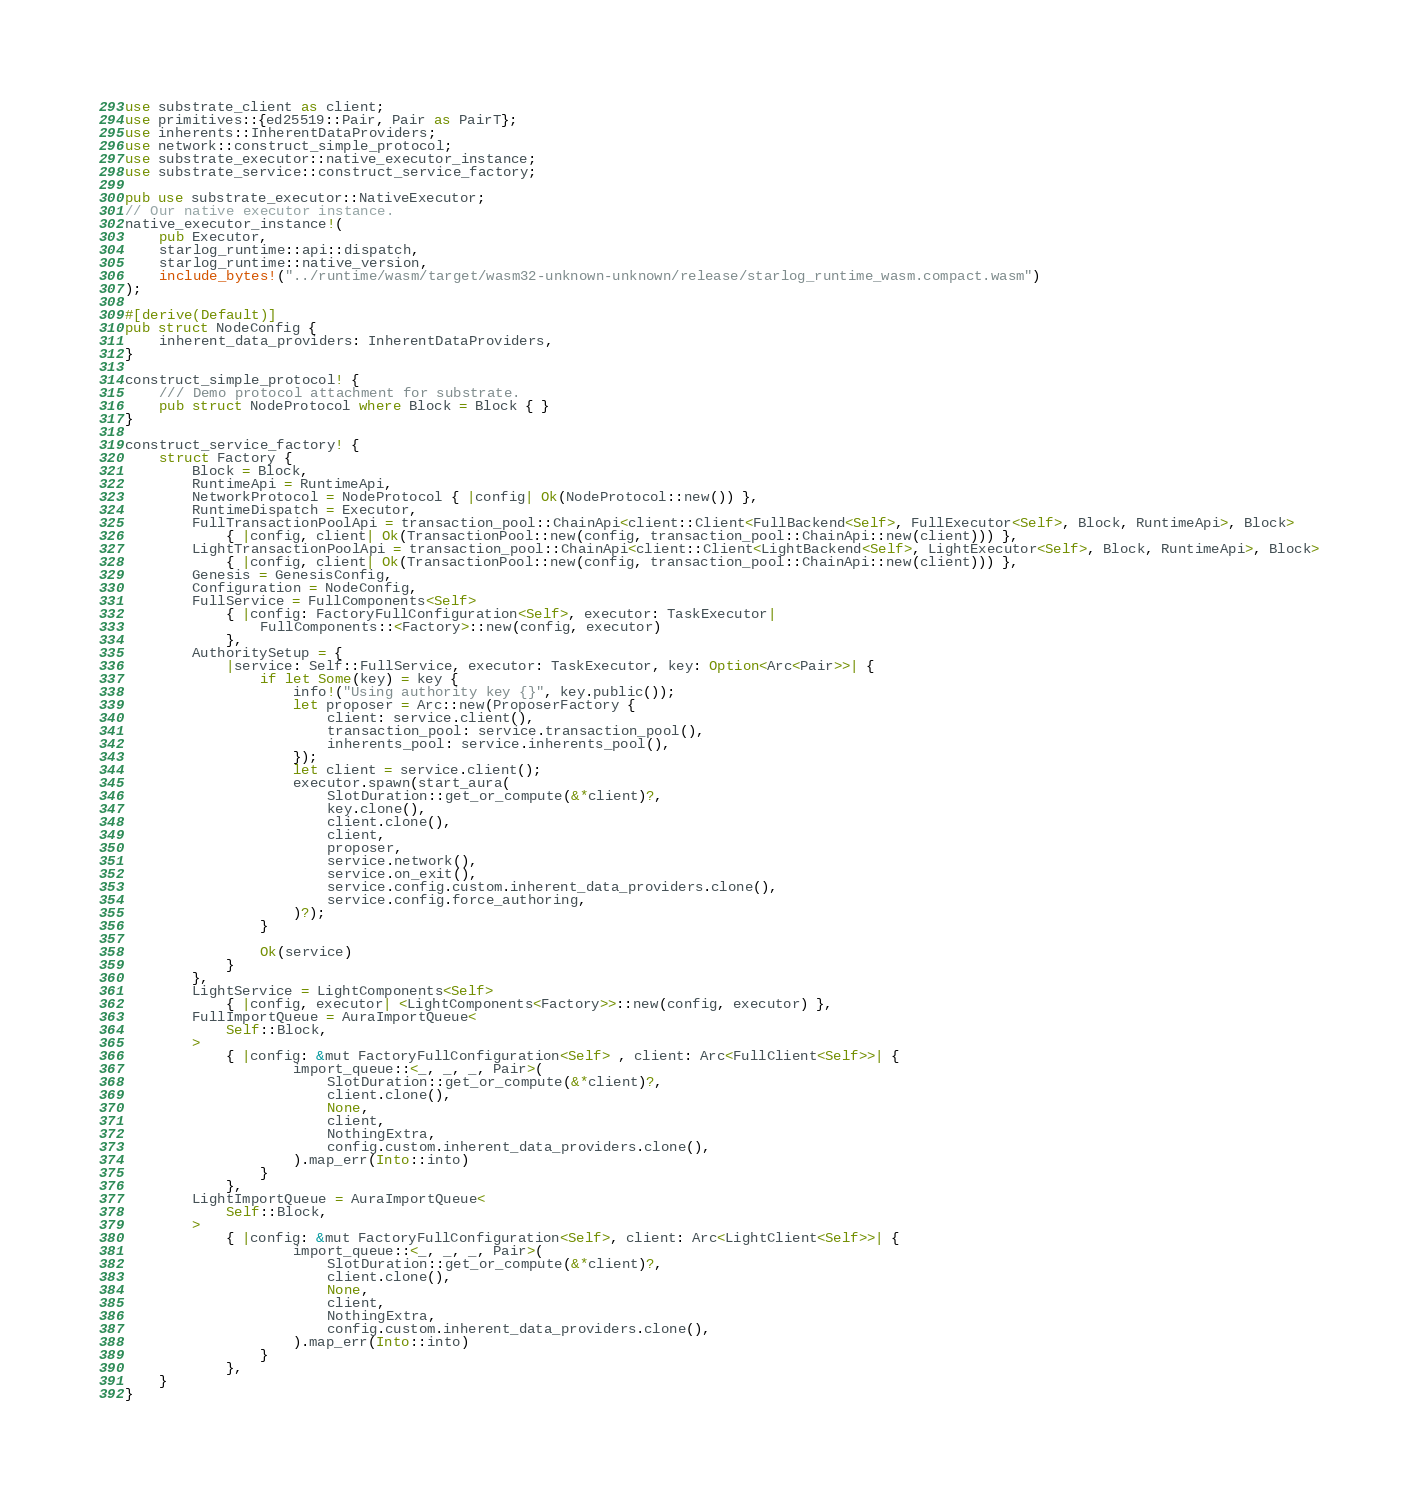Convert code to text. <code><loc_0><loc_0><loc_500><loc_500><_Rust_>use substrate_client as client;
use primitives::{ed25519::Pair, Pair as PairT};
use inherents::InherentDataProviders;
use network::construct_simple_protocol;
use substrate_executor::native_executor_instance;
use substrate_service::construct_service_factory;

pub use substrate_executor::NativeExecutor;
// Our native executor instance.
native_executor_instance!(
	pub Executor,
	starlog_runtime::api::dispatch,
	starlog_runtime::native_version,
	include_bytes!("../runtime/wasm/target/wasm32-unknown-unknown/release/starlog_runtime_wasm.compact.wasm")
);

#[derive(Default)]
pub struct NodeConfig {
	inherent_data_providers: InherentDataProviders,
}

construct_simple_protocol! {
	/// Demo protocol attachment for substrate.
	pub struct NodeProtocol where Block = Block { }
}

construct_service_factory! {
	struct Factory {
		Block = Block,
		RuntimeApi = RuntimeApi,
		NetworkProtocol = NodeProtocol { |config| Ok(NodeProtocol::new()) },
		RuntimeDispatch = Executor,
		FullTransactionPoolApi = transaction_pool::ChainApi<client::Client<FullBackend<Self>, FullExecutor<Self>, Block, RuntimeApi>, Block>
			{ |config, client| Ok(TransactionPool::new(config, transaction_pool::ChainApi::new(client))) },
		LightTransactionPoolApi = transaction_pool::ChainApi<client::Client<LightBackend<Self>, LightExecutor<Self>, Block, RuntimeApi>, Block>
			{ |config, client| Ok(TransactionPool::new(config, transaction_pool::ChainApi::new(client))) },
		Genesis = GenesisConfig,
		Configuration = NodeConfig,
		FullService = FullComponents<Self>
			{ |config: FactoryFullConfiguration<Self>, executor: TaskExecutor|
				FullComponents::<Factory>::new(config, executor)
			},
		AuthoritySetup = {
			|service: Self::FullService, executor: TaskExecutor, key: Option<Arc<Pair>>| {
				if let Some(key) = key {
					info!("Using authority key {}", key.public());
					let proposer = Arc::new(ProposerFactory {
						client: service.client(),
						transaction_pool: service.transaction_pool(),
						inherents_pool: service.inherents_pool(),
					});
					let client = service.client();
					executor.spawn(start_aura(
						SlotDuration::get_or_compute(&*client)?,
						key.clone(),
						client.clone(),
						client,
						proposer,
						service.network(),
						service.on_exit(),
						service.config.custom.inherent_data_providers.clone(),
						service.config.force_authoring,
					)?);
				}

				Ok(service)
			}
		},
		LightService = LightComponents<Self>
			{ |config, executor| <LightComponents<Factory>>::new(config, executor) },
		FullImportQueue = AuraImportQueue<
			Self::Block,
		>
			{ |config: &mut FactoryFullConfiguration<Self> , client: Arc<FullClient<Self>>| {
					import_queue::<_, _, _, Pair>(
						SlotDuration::get_or_compute(&*client)?,
						client.clone(),
						None,
						client,
						NothingExtra,
						config.custom.inherent_data_providers.clone(),
					).map_err(Into::into)
				}
			},
		LightImportQueue = AuraImportQueue<
			Self::Block,
		>
			{ |config: &mut FactoryFullConfiguration<Self>, client: Arc<LightClient<Self>>| {
					import_queue::<_, _, _, Pair>(
						SlotDuration::get_or_compute(&*client)?,
						client.clone(),
						None,
						client,
						NothingExtra,
						config.custom.inherent_data_providers.clone(),
					).map_err(Into::into)
				}
			},
	}
}</code> 